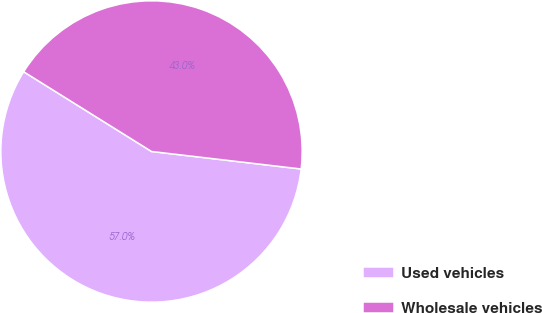Convert chart to OTSL. <chart><loc_0><loc_0><loc_500><loc_500><pie_chart><fcel>Used vehicles<fcel>Wholesale vehicles<nl><fcel>57.02%<fcel>42.98%<nl></chart> 